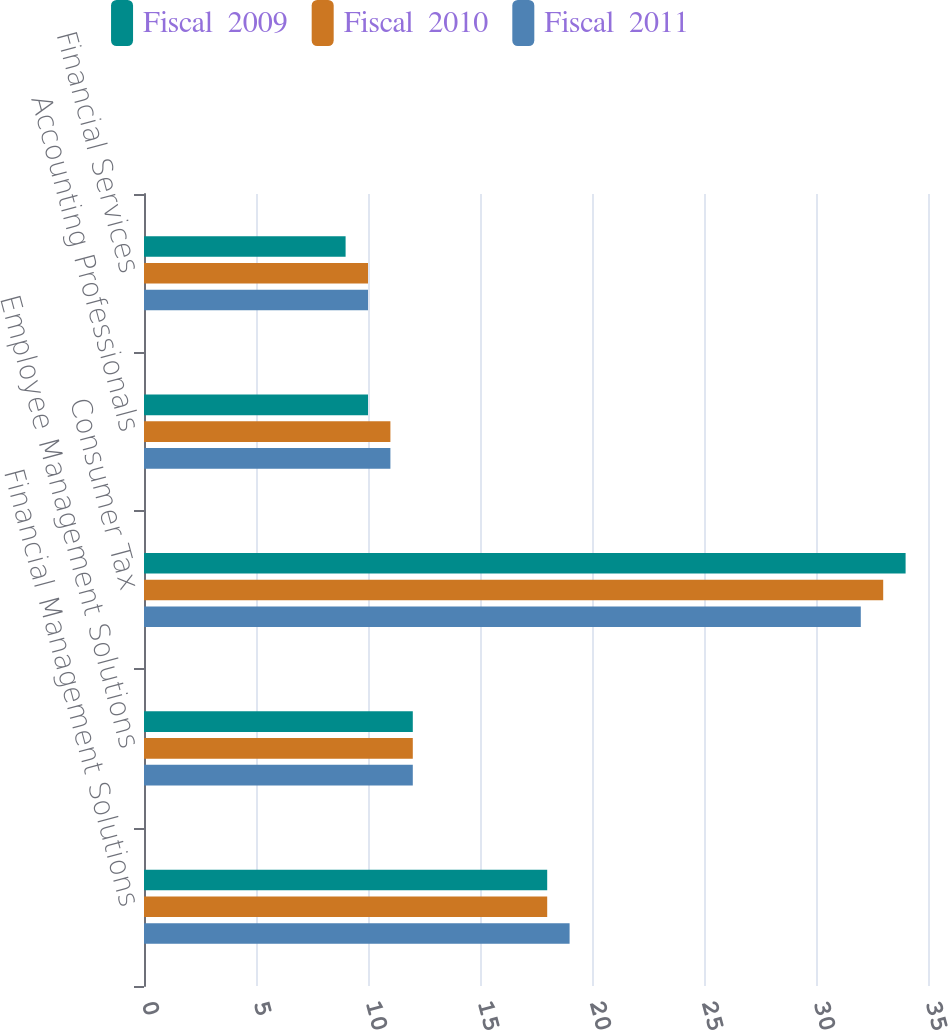<chart> <loc_0><loc_0><loc_500><loc_500><stacked_bar_chart><ecel><fcel>Financial Management Solutions<fcel>Employee Management Solutions<fcel>Consumer Tax<fcel>Accounting Professionals<fcel>Financial Services<nl><fcel>Fiscal  2009<fcel>18<fcel>12<fcel>34<fcel>10<fcel>9<nl><fcel>Fiscal  2010<fcel>18<fcel>12<fcel>33<fcel>11<fcel>10<nl><fcel>Fiscal  2011<fcel>19<fcel>12<fcel>32<fcel>11<fcel>10<nl></chart> 